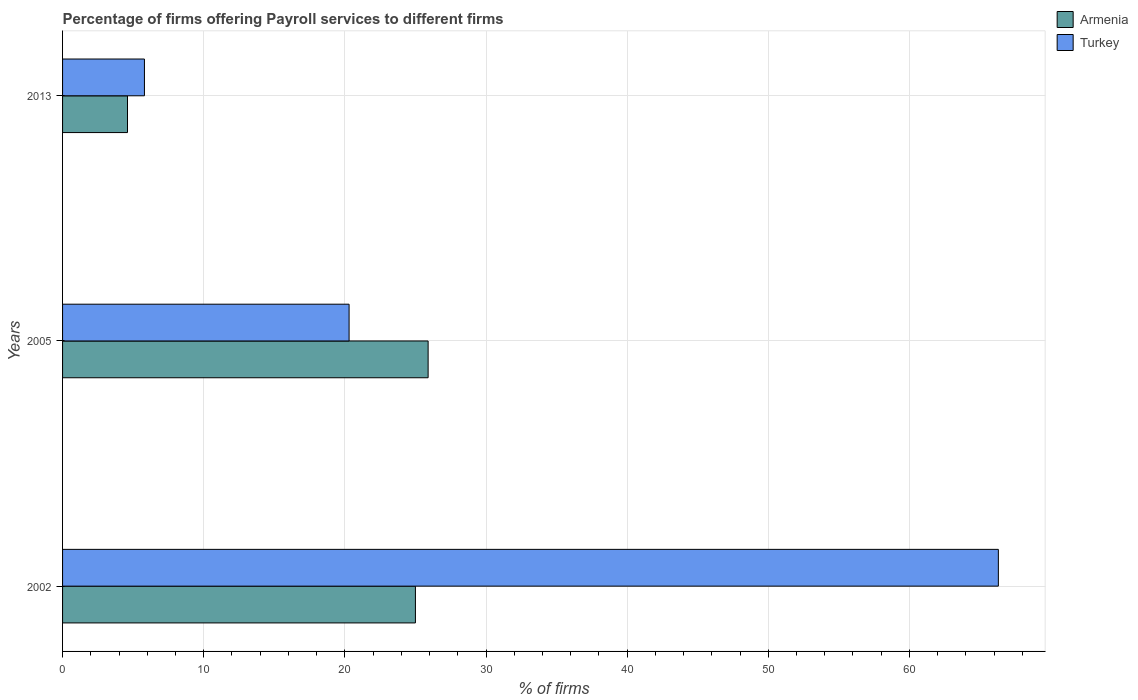How many groups of bars are there?
Your answer should be compact. 3. What is the label of the 3rd group of bars from the top?
Keep it short and to the point. 2002. Across all years, what is the maximum percentage of firms offering payroll services in Turkey?
Your response must be concise. 66.3. Across all years, what is the minimum percentage of firms offering payroll services in Armenia?
Your answer should be compact. 4.6. In which year was the percentage of firms offering payroll services in Armenia minimum?
Give a very brief answer. 2013. What is the total percentage of firms offering payroll services in Turkey in the graph?
Provide a succinct answer. 92.4. What is the difference between the percentage of firms offering payroll services in Armenia in 2005 and the percentage of firms offering payroll services in Turkey in 2013?
Your response must be concise. 20.1. What is the average percentage of firms offering payroll services in Armenia per year?
Give a very brief answer. 18.5. In the year 2002, what is the difference between the percentage of firms offering payroll services in Armenia and percentage of firms offering payroll services in Turkey?
Offer a very short reply. -41.3. In how many years, is the percentage of firms offering payroll services in Turkey greater than 60 %?
Provide a short and direct response. 1. What is the ratio of the percentage of firms offering payroll services in Armenia in 2005 to that in 2013?
Provide a short and direct response. 5.63. Is the percentage of firms offering payroll services in Armenia in 2005 less than that in 2013?
Give a very brief answer. No. What is the difference between the highest and the second highest percentage of firms offering payroll services in Turkey?
Your answer should be compact. 46. What is the difference between the highest and the lowest percentage of firms offering payroll services in Turkey?
Keep it short and to the point. 60.5. What does the 2nd bar from the bottom in 2002 represents?
Provide a succinct answer. Turkey. How many bars are there?
Provide a short and direct response. 6. Are all the bars in the graph horizontal?
Provide a succinct answer. Yes. What is the difference between two consecutive major ticks on the X-axis?
Make the answer very short. 10. Are the values on the major ticks of X-axis written in scientific E-notation?
Your response must be concise. No. How many legend labels are there?
Your answer should be compact. 2. What is the title of the graph?
Make the answer very short. Percentage of firms offering Payroll services to different firms. Does "Qatar" appear as one of the legend labels in the graph?
Ensure brevity in your answer.  No. What is the label or title of the X-axis?
Offer a terse response. % of firms. What is the label or title of the Y-axis?
Offer a very short reply. Years. What is the % of firms of Turkey in 2002?
Keep it short and to the point. 66.3. What is the % of firms in Armenia in 2005?
Ensure brevity in your answer.  25.9. What is the % of firms of Turkey in 2005?
Offer a terse response. 20.3. What is the % of firms of Turkey in 2013?
Make the answer very short. 5.8. Across all years, what is the maximum % of firms in Armenia?
Make the answer very short. 25.9. Across all years, what is the maximum % of firms of Turkey?
Offer a terse response. 66.3. Across all years, what is the minimum % of firms in Armenia?
Your answer should be very brief. 4.6. What is the total % of firms of Armenia in the graph?
Your answer should be very brief. 55.5. What is the total % of firms in Turkey in the graph?
Offer a very short reply. 92.4. What is the difference between the % of firms of Turkey in 2002 and that in 2005?
Offer a terse response. 46. What is the difference between the % of firms of Armenia in 2002 and that in 2013?
Keep it short and to the point. 20.4. What is the difference between the % of firms of Turkey in 2002 and that in 2013?
Ensure brevity in your answer.  60.5. What is the difference between the % of firms in Armenia in 2005 and that in 2013?
Offer a terse response. 21.3. What is the difference between the % of firms of Armenia in 2002 and the % of firms of Turkey in 2005?
Your answer should be compact. 4.7. What is the difference between the % of firms of Armenia in 2005 and the % of firms of Turkey in 2013?
Your answer should be very brief. 20.1. What is the average % of firms in Turkey per year?
Your answer should be very brief. 30.8. In the year 2002, what is the difference between the % of firms of Armenia and % of firms of Turkey?
Give a very brief answer. -41.3. What is the ratio of the % of firms in Armenia in 2002 to that in 2005?
Provide a succinct answer. 0.97. What is the ratio of the % of firms in Turkey in 2002 to that in 2005?
Provide a short and direct response. 3.27. What is the ratio of the % of firms of Armenia in 2002 to that in 2013?
Your answer should be very brief. 5.43. What is the ratio of the % of firms in Turkey in 2002 to that in 2013?
Provide a succinct answer. 11.43. What is the ratio of the % of firms in Armenia in 2005 to that in 2013?
Give a very brief answer. 5.63. What is the difference between the highest and the lowest % of firms of Armenia?
Your answer should be very brief. 21.3. What is the difference between the highest and the lowest % of firms in Turkey?
Give a very brief answer. 60.5. 